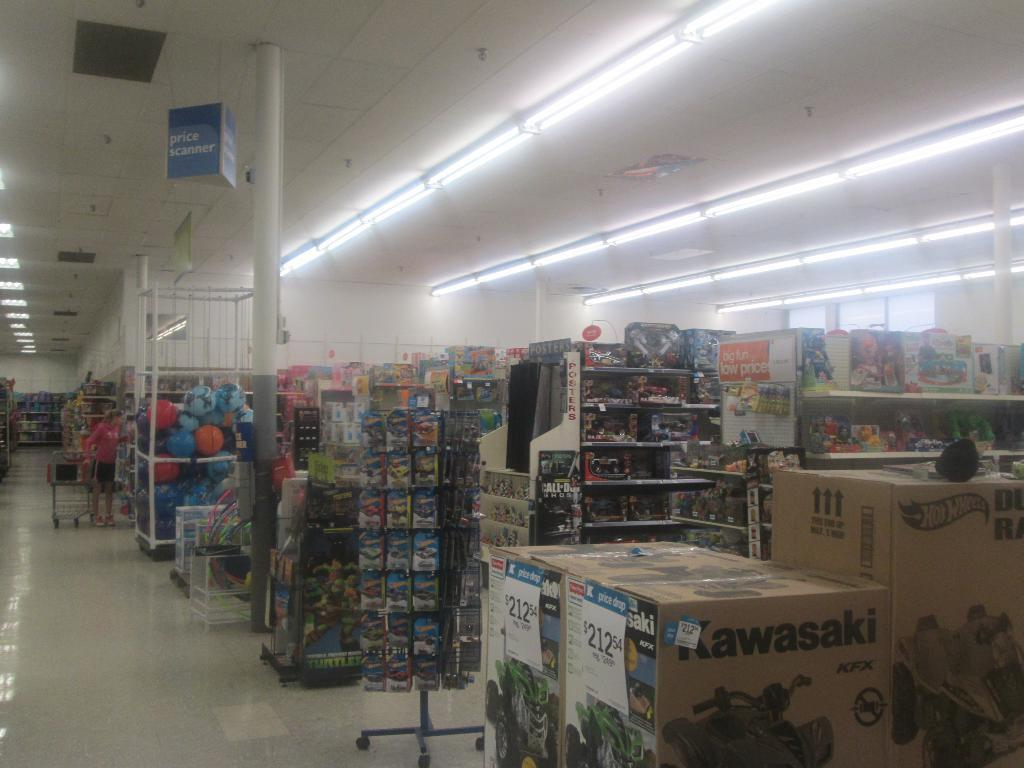<image>
Summarize the visual content of the image. Kawasaki brand items are for sell in a store. 